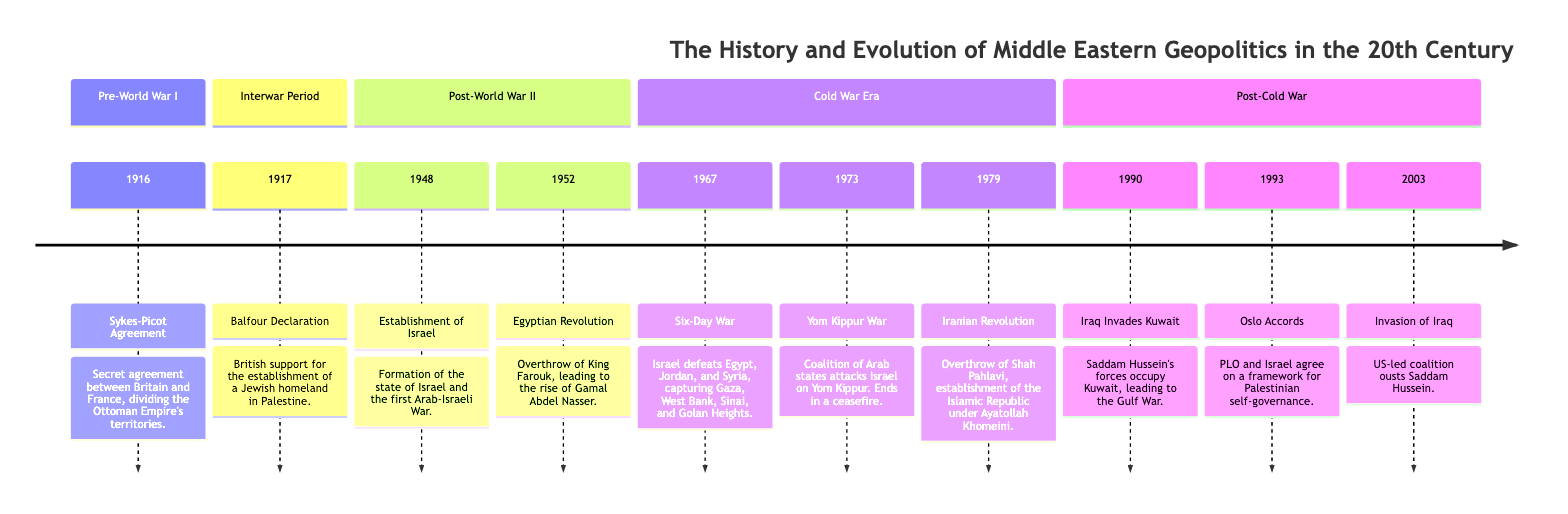What significant agreement was made in 1916? The diagram indicates that the Sykes-Picot Agreement was established in 1916, which was a secret arrangement between Britain and France to divide the Ottoman Empire's territories.
Answer: Sykes-Picot Agreement What event marked the establishment of Israel? According to the timeline, the establishment of Israel occurred in 1948, coinciding with the first Arab-Israeli War.
Answer: 1948 Which war is associated with the year 1967? The diagram explicitly states that the Six-Day War occurred in 1967, during which Israel defeated Egypt, Jordan, and Syria.
Answer: Six-Day War What led to the rise of Gamal Abdel Nasser? The diagram shows that the Egyptian Revolution in 1952 resulted in the overthrow of King Farouk, which facilitated Gamal Abdel Nasser's rise.
Answer: Egyptian Revolution Which event is described as ending in a ceasefire and involved a coalition of Arab states? The Yom Kippur War is noted in the diagram as involving a coalition of Arab states attacking Israel and ending in a ceasefire, which identifies it specifically with this event.
Answer: Yom Kippur War What major geopolitical event happened in 1993? The Oslo Accords, which established a framework for Palestinian self-governance, occurred in 1993 as indicated in the timeline.
Answer: Oslo Accords How many significant events are listed in the Post-Cold War section? By examining the diagram, I can count three significant events listed under the Post-Cold War section: Iraq Invades Kuwait, Oslo Accords, and Invasion of Iraq.
Answer: 3 What was the outcome of the Iranian Revolution in 1979? The diagram indicates that the Iranian Revolution led to the establishment of the Islamic Republic under Ayatollah Khomeini after the overthrow of Shah Pahlavi.
Answer: Islamic Republic What year did Iraq invade Kuwait? From the timeline, it is clear that Iraq invaded Kuwait in 1990, leading to the Gulf War.
Answer: 1990 What event shifted power dynamics significantly in the Middle East during the Cold War Era? The Six-Day War in 1967 is highlighted in the diagram as a significant shift in power dynamics, showcasing Israel’s military success over neighboring Arab states.
Answer: Six-Day War 